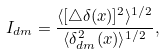<formula> <loc_0><loc_0><loc_500><loc_500>I _ { d m } = \frac { \langle [ \bigtriangleup \delta ( { x } ) ] ^ { 2 } \rangle ^ { 1 / 2 } } { \langle \delta ^ { 2 } _ { d m } ( { x } ) \rangle ^ { 1 / 2 } } ,</formula> 